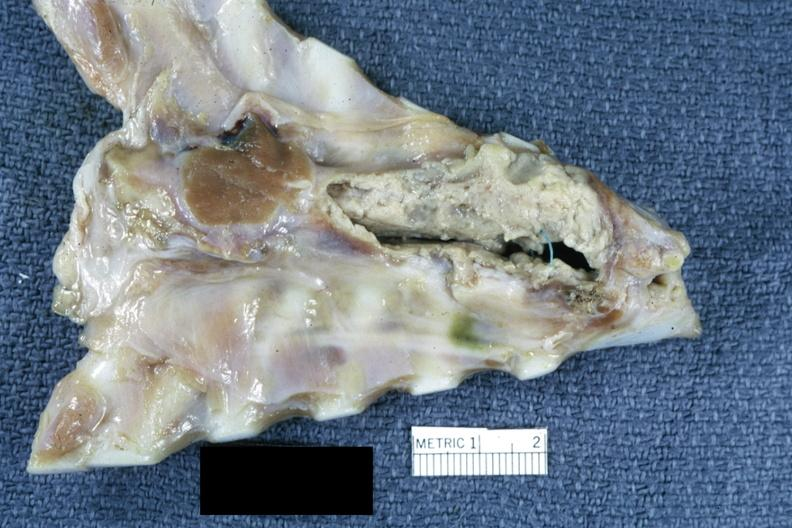where is this?
Answer the question using a single word or phrase. Thorax 